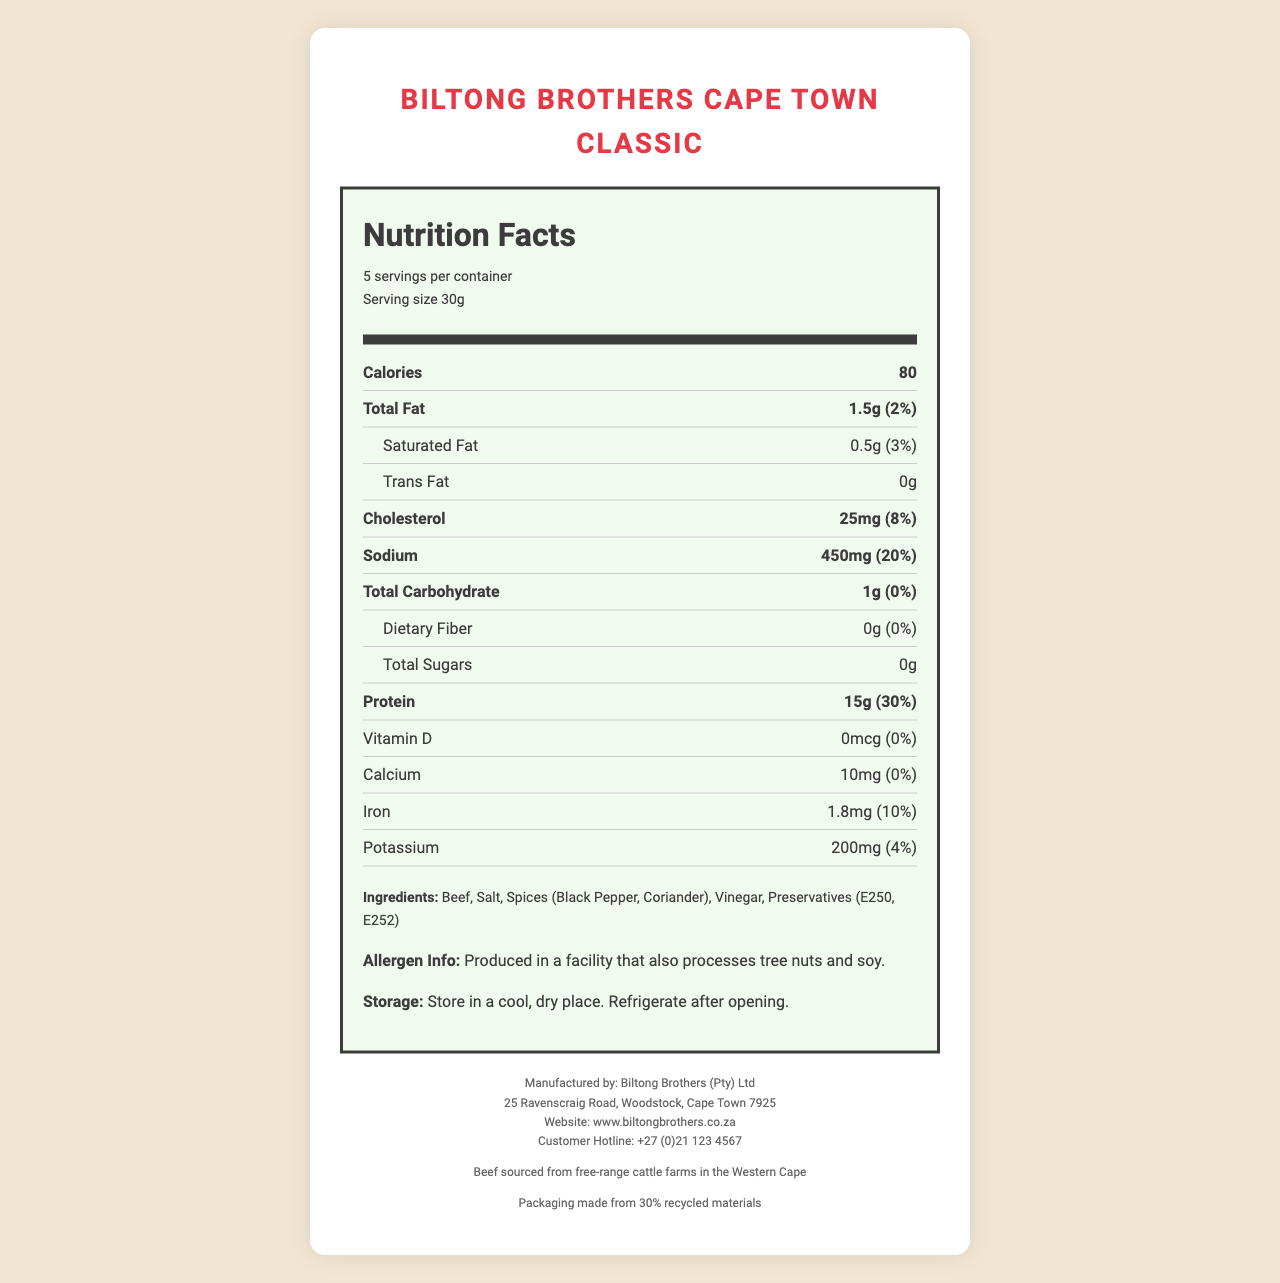what is the serving size? The document lists the serving size as "30g" under the serving information section.
Answer: 30g how much protein is in one serving of Biltong Brothers Cape Town Classic? The document shows that each serving contains 15g of protein.
Answer: 15g what is the daily value percentage of sodium per serving? The sodium section of the nutrition label indicates that the daily value percentage per serving is 20%.
Answer: 20% how many servings are in one container? The document states that there are 5 servings per container.
Answer: 5 who manufactures the Biltong Brothers Cape Town Classic? The manufacturer information at the bottom mentions that it is produced by Biltong Brothers (Pty) Ltd.
Answer: Biltong Brothers (Pty) Ltd On which road is the manufacturing address located? A. Ravenscraig Road B. Long Street C. Kloof Street D. Main Road The address provided in the document is "25 Ravenscraig Road, Woodstock, Cape Town 7925," indicating Ravenscraig Road as the location.
Answer: A. Ravenscraig Road What is the total fat content per serving? A. 1g B. 1.5g C. 2g D. 2.5g The nutrition facts indicate that the total fat per serving is 1.5g.
Answer: B. 1.5g Does the product contain any dietary fiber? According to the nutrition label, the dietary fiber content is listed as 0g, indicating no dietary fiber in the product.
Answer: No Describe the main idea of the document. The document outlines the nutritional values, ingredients, and manufacturing information of Biltong Brothers Cape Town Classic biltong to inform consumers.
Answer: The document is a detailed nutrition facts label for Biltong Brothers Cape Town Classic, providing information on serving size, nutritional content per serving, ingredients, allergen info, and manufacturing details. Can you identify how many preservatives are listed in the ingredients? The document mentions "Preservatives (E250, E252)" under the ingredients, but it only provides the codes without detailing how many different types or amounts each represents.
Answer: Not enough information 